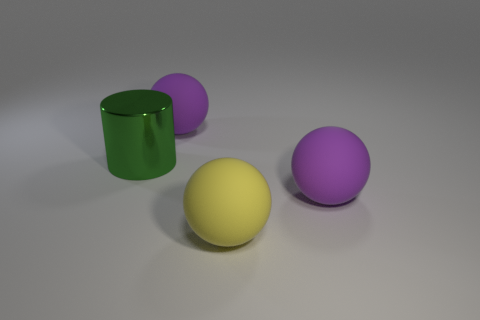How are the objects arranged in relation to each other? The objects in the image are spread out on a flat surface. In the center is a yellow sphere, and to the left of it is a green cylinder standing upright. To the right of the yellow sphere, there are two purple spheres at varying distances. All objects are spaced in a way that none of them touch each other, creating a scene with a balanced sense of space between the items. 